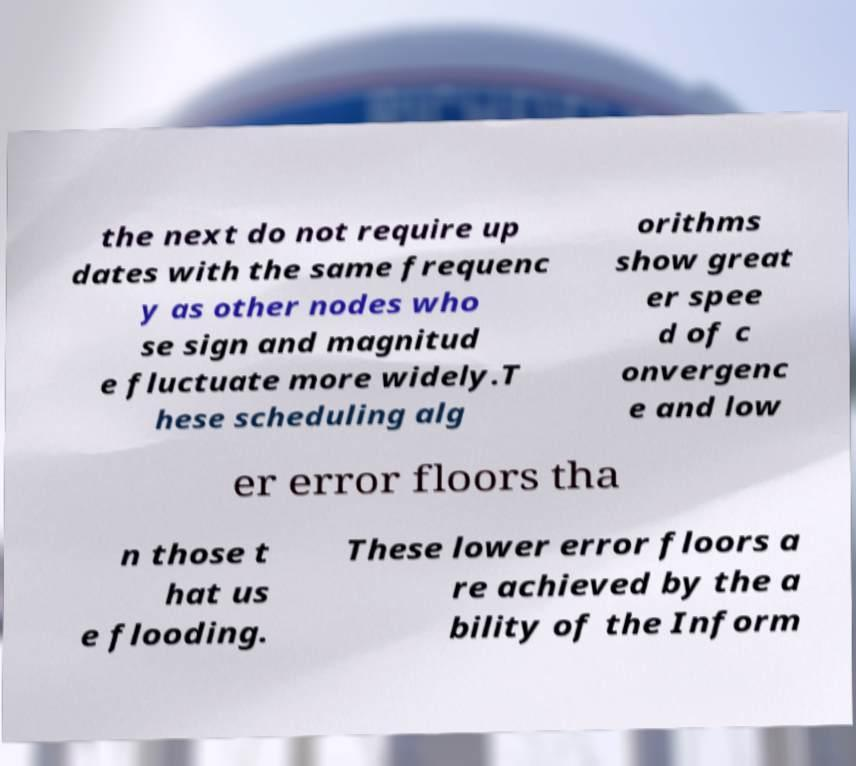Can you read and provide the text displayed in the image?This photo seems to have some interesting text. Can you extract and type it out for me? the next do not require up dates with the same frequenc y as other nodes who se sign and magnitud e fluctuate more widely.T hese scheduling alg orithms show great er spee d of c onvergenc e and low er error floors tha n those t hat us e flooding. These lower error floors a re achieved by the a bility of the Inform 